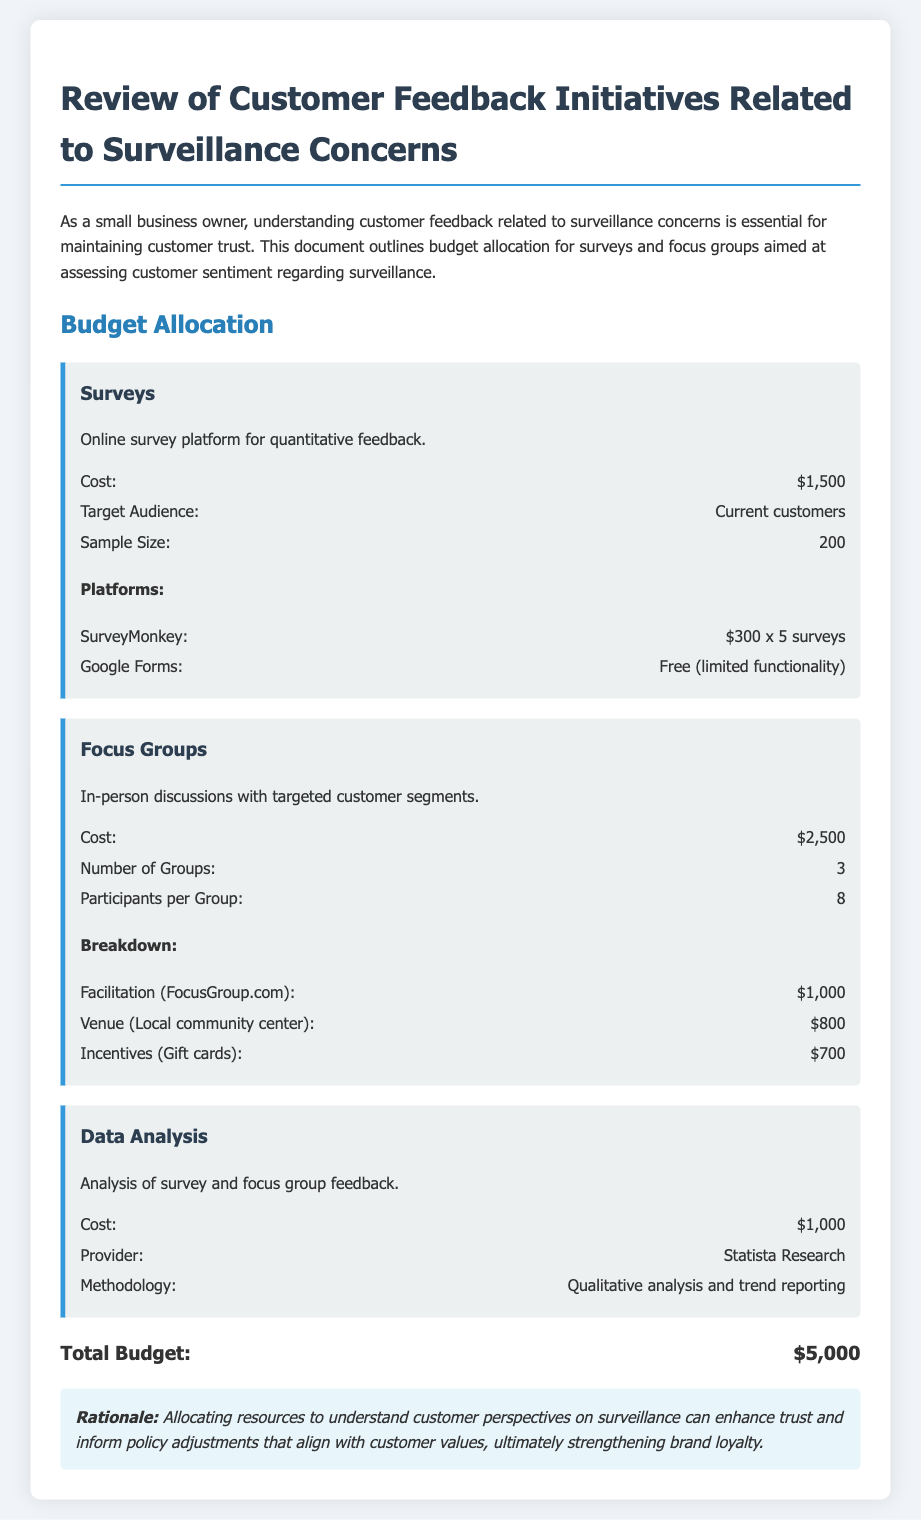what is the total budget? The total budget is the sum of all allocated costs in the document, specifically for surveys, focus groups, and data analysis, which totals $1,500 + $2,500 + $1,000.
Answer: $5,000 how much does the focus group facilitation cost? The focus group facilitation cost is specifically listed in the budget as $1,000.
Answer: $1,000 how many participants are in each focus group? The number of participants per focus group is indicated in the budget breakdown, which states there are 8 participants.
Answer: 8 what is the cost of online surveys? The cost for online surveys, as detailed in the budget section, is $1,500.
Answer: $1,500 how many surveys will be conducted? The document states that 5 surveys will be conducted, as noted in the online survey platform breakdown.
Answer: 5 what is the rationale for this budget allocation? The rationale provided in the document suggests that understanding customer perspectives on surveillance can enhance trust and inform policy adjustments.
Answer: Enhance trust what is the sample size for the online surveys? The sample size for the online surveys is explicitly stated in the document as 200.
Answer: 200 how many focus groups are planned according to the budget? The budget indicates that there are 3 focus groups planned for customer feedback.
Answer: 3 who is the provider for data analysis? The document names Statista Research as the provider for data analysis, which is mentioned in the data analysis section.
Answer: Statista Research 